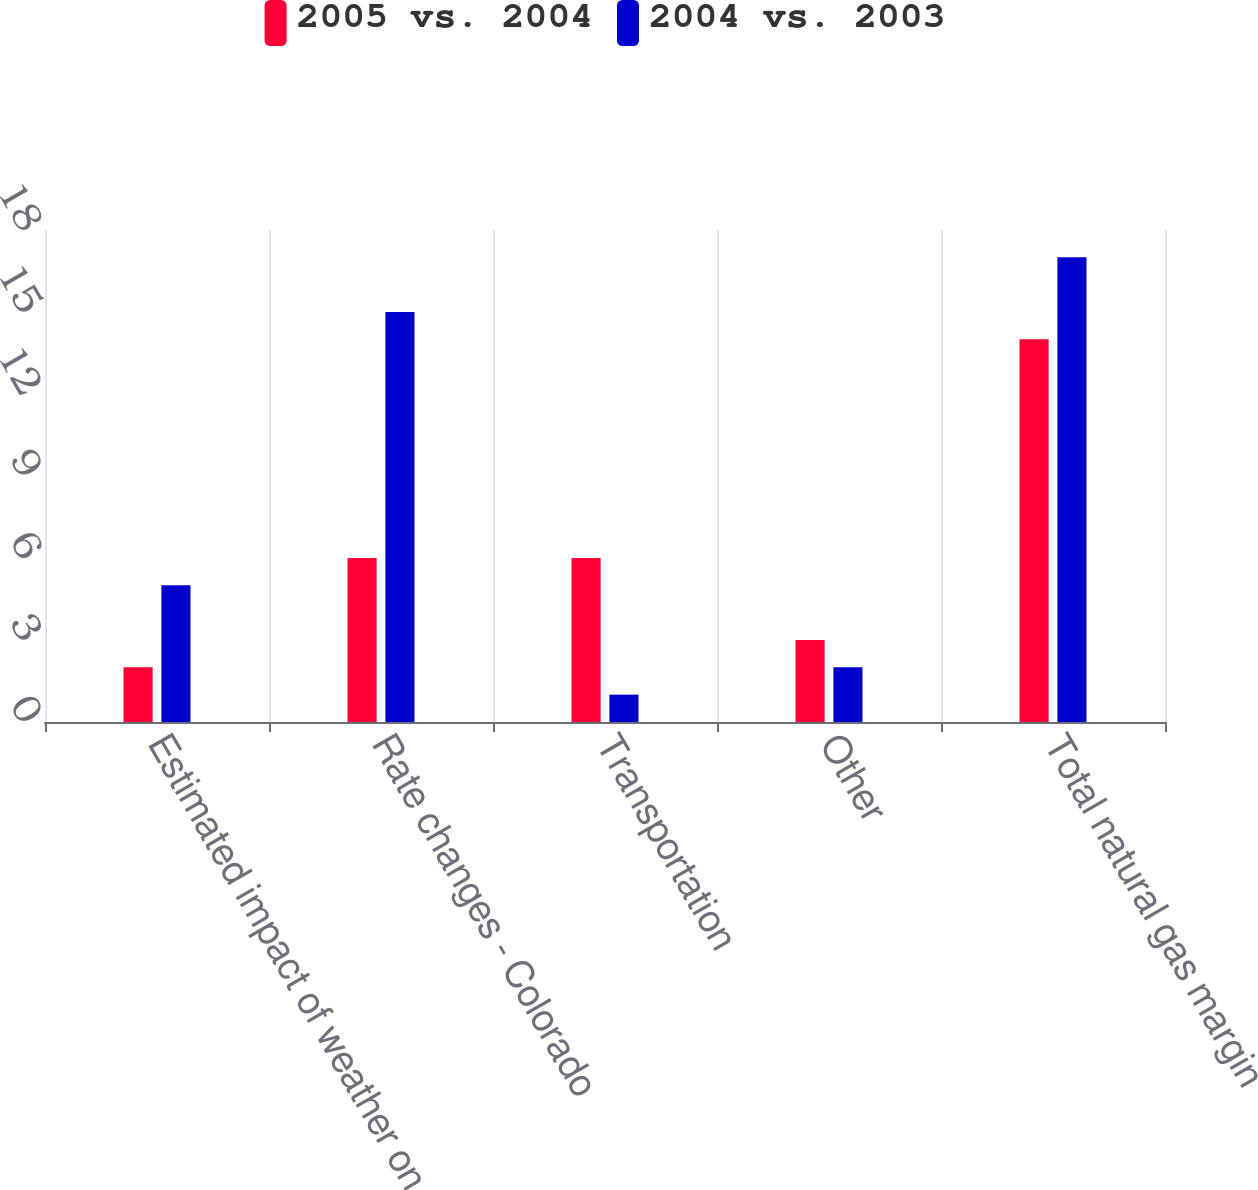<chart> <loc_0><loc_0><loc_500><loc_500><stacked_bar_chart><ecel><fcel>Estimated impact of weather on<fcel>Rate changes - Colorado<fcel>Transportation<fcel>Other<fcel>Total natural gas margin<nl><fcel>2005 vs. 2004<fcel>2<fcel>6<fcel>6<fcel>3<fcel>14<nl><fcel>2004 vs. 2003<fcel>5<fcel>15<fcel>1<fcel>2<fcel>17<nl></chart> 